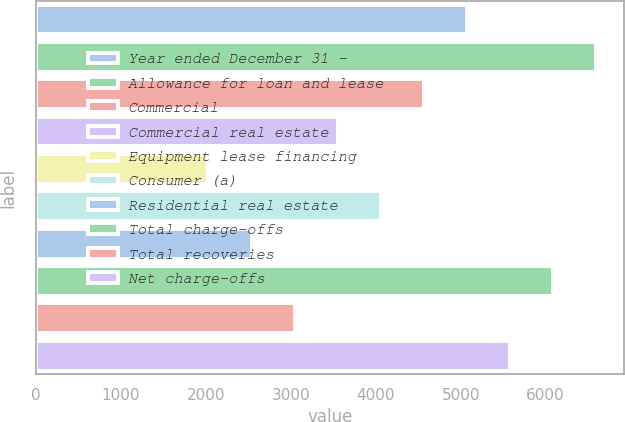Convert chart to OTSL. <chart><loc_0><loc_0><loc_500><loc_500><bar_chart><fcel>Year ended December 31 -<fcel>Allowance for loan and lease<fcel>Commercial<fcel>Commercial real estate<fcel>Equipment lease financing<fcel>Consumer (a)<fcel>Residential real estate<fcel>Total charge-offs<fcel>Total recoveries<fcel>Net charge-offs<nl><fcel>5071.96<fcel>6592.63<fcel>4565.07<fcel>3551.29<fcel>2030.62<fcel>4058.18<fcel>2537.51<fcel>6085.74<fcel>3044.4<fcel>5578.85<nl></chart> 